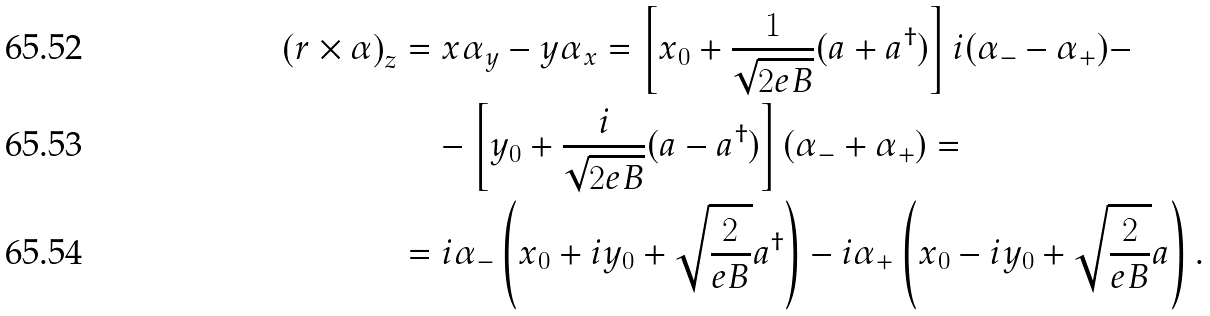<formula> <loc_0><loc_0><loc_500><loc_500>\left ( r \times \alpha \right ) _ { z } & = x \alpha _ { y } - y \alpha _ { x } = \left [ x _ { 0 } + \frac { 1 } { \sqrt { 2 e B } } ( a + a ^ { \dag } ) \right ] i ( \alpha _ { - } - \alpha _ { + } ) - \\ & \quad - \left [ y _ { 0 } + \frac { i } { \sqrt { 2 e B } } ( a - a ^ { \dag } ) \right ] ( \alpha _ { - } + \alpha _ { + } ) = \\ & = i \alpha _ { - } \left ( x _ { 0 } + i y _ { 0 } + \sqrt { \frac { 2 } { e B } } a ^ { \dag } \right ) - i \alpha _ { + } \left ( x _ { 0 } - i y _ { 0 } + \sqrt { \frac { 2 } { e B } } a \right ) .</formula> 